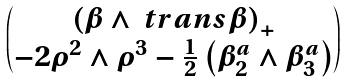<formula> <loc_0><loc_0><loc_500><loc_500>\begin{pmatrix} \left ( \beta \wedge \ t r a n s { \beta } \right ) _ { + } \\ - 2 \rho ^ { 2 } \wedge \rho ^ { 3 } - \frac { 1 } { 2 } \left ( \beta ^ { a } _ { 2 } \wedge \beta ^ { a } _ { 3 } \right ) \end{pmatrix}</formula> 